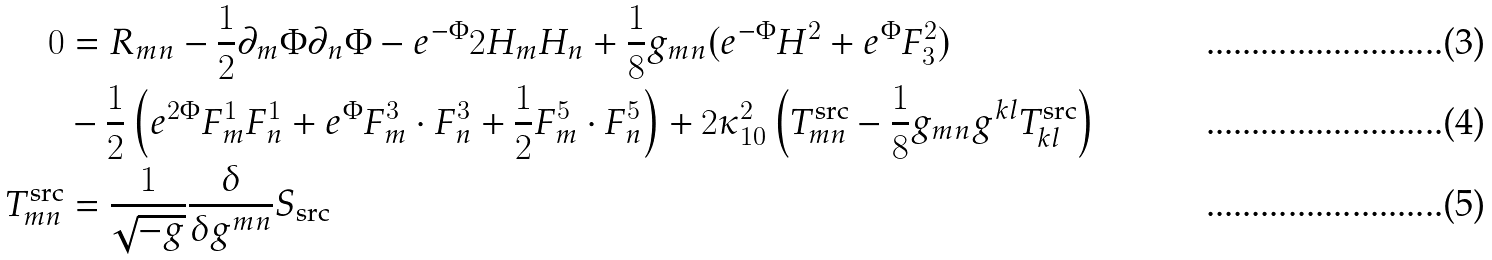<formula> <loc_0><loc_0><loc_500><loc_500>0 & = R _ { m n } - \frac { 1 } { 2 } \partial _ { m } \Phi \partial _ { n } \Phi - e ^ { - \Phi } { 2 } H _ { m } H _ { n } + \frac { 1 } { 8 } g _ { m n } ( e ^ { - \Phi } H ^ { 2 } + e ^ { \Phi } F _ { 3 } ^ { 2 } ) \\ & - \frac { 1 } { 2 } \left ( e ^ { 2 \Phi } F ^ { 1 } _ { m } F ^ { 1 } _ { n } + e ^ { \Phi } F ^ { 3 } _ { m } \cdot F ^ { 3 } _ { n } + \frac { 1 } { 2 } F ^ { 5 } _ { m } \cdot F ^ { 5 } _ { n } \right ) + 2 \kappa _ { 1 0 } ^ { 2 } \left ( T ^ { \text {src} } _ { m n } - \frac { 1 } { 8 } g _ { m n } g ^ { k l } T ^ { \text {src} } _ { k l } \right ) \\ T ^ { \text {src} } _ { m n } & = \frac { 1 } { \sqrt { - g } } \frac { \delta } { \delta g ^ { m n } } S _ { \text {src} }</formula> 